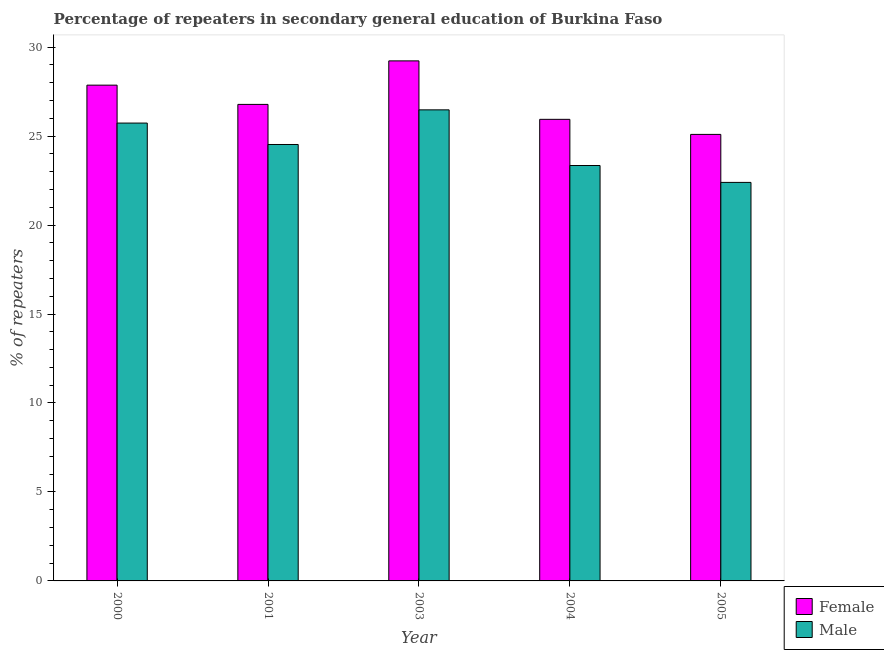How many different coloured bars are there?
Your answer should be compact. 2. How many groups of bars are there?
Your answer should be very brief. 5. Are the number of bars per tick equal to the number of legend labels?
Provide a succinct answer. Yes. How many bars are there on the 2nd tick from the left?
Provide a short and direct response. 2. What is the label of the 2nd group of bars from the left?
Give a very brief answer. 2001. In how many cases, is the number of bars for a given year not equal to the number of legend labels?
Make the answer very short. 0. What is the percentage of male repeaters in 2000?
Keep it short and to the point. 25.73. Across all years, what is the maximum percentage of female repeaters?
Your response must be concise. 29.23. Across all years, what is the minimum percentage of female repeaters?
Provide a short and direct response. 25.1. In which year was the percentage of male repeaters minimum?
Provide a succinct answer. 2005. What is the total percentage of male repeaters in the graph?
Make the answer very short. 122.48. What is the difference between the percentage of male repeaters in 2001 and that in 2005?
Offer a terse response. 2.13. What is the difference between the percentage of male repeaters in 2001 and the percentage of female repeaters in 2000?
Make the answer very short. -1.2. What is the average percentage of male repeaters per year?
Offer a terse response. 24.5. In how many years, is the percentage of female repeaters greater than 7 %?
Offer a very short reply. 5. What is the ratio of the percentage of male repeaters in 2001 to that in 2004?
Your response must be concise. 1.05. Is the difference between the percentage of male repeaters in 2001 and 2004 greater than the difference between the percentage of female repeaters in 2001 and 2004?
Make the answer very short. No. What is the difference between the highest and the second highest percentage of male repeaters?
Keep it short and to the point. 0.74. What is the difference between the highest and the lowest percentage of female repeaters?
Your answer should be compact. 4.13. Is the sum of the percentage of female repeaters in 2000 and 2003 greater than the maximum percentage of male repeaters across all years?
Your answer should be compact. Yes. What does the 2nd bar from the right in 2000 represents?
Ensure brevity in your answer.  Female. How many bars are there?
Your answer should be compact. 10. Are the values on the major ticks of Y-axis written in scientific E-notation?
Give a very brief answer. No. Does the graph contain any zero values?
Make the answer very short. No. How many legend labels are there?
Offer a very short reply. 2. What is the title of the graph?
Your response must be concise. Percentage of repeaters in secondary general education of Burkina Faso. What is the label or title of the X-axis?
Keep it short and to the point. Year. What is the label or title of the Y-axis?
Your answer should be very brief. % of repeaters. What is the % of repeaters in Female in 2000?
Provide a succinct answer. 27.86. What is the % of repeaters of Male in 2000?
Give a very brief answer. 25.73. What is the % of repeaters in Female in 2001?
Your response must be concise. 26.78. What is the % of repeaters in Male in 2001?
Provide a succinct answer. 24.53. What is the % of repeaters in Female in 2003?
Provide a short and direct response. 29.23. What is the % of repeaters of Male in 2003?
Provide a succinct answer. 26.48. What is the % of repeaters of Female in 2004?
Your answer should be compact. 25.94. What is the % of repeaters in Male in 2004?
Provide a short and direct response. 23.35. What is the % of repeaters of Female in 2005?
Provide a short and direct response. 25.1. What is the % of repeaters in Male in 2005?
Keep it short and to the point. 22.4. Across all years, what is the maximum % of repeaters of Female?
Give a very brief answer. 29.23. Across all years, what is the maximum % of repeaters in Male?
Make the answer very short. 26.48. Across all years, what is the minimum % of repeaters of Female?
Keep it short and to the point. 25.1. Across all years, what is the minimum % of repeaters of Male?
Your answer should be compact. 22.4. What is the total % of repeaters in Female in the graph?
Your answer should be very brief. 134.91. What is the total % of repeaters in Male in the graph?
Ensure brevity in your answer.  122.48. What is the difference between the % of repeaters in Female in 2000 and that in 2001?
Offer a terse response. 1.08. What is the difference between the % of repeaters in Male in 2000 and that in 2001?
Keep it short and to the point. 1.2. What is the difference between the % of repeaters in Female in 2000 and that in 2003?
Keep it short and to the point. -1.36. What is the difference between the % of repeaters of Male in 2000 and that in 2003?
Provide a succinct answer. -0.74. What is the difference between the % of repeaters in Female in 2000 and that in 2004?
Your answer should be compact. 1.92. What is the difference between the % of repeaters of Male in 2000 and that in 2004?
Offer a very short reply. 2.39. What is the difference between the % of repeaters of Female in 2000 and that in 2005?
Give a very brief answer. 2.77. What is the difference between the % of repeaters of Male in 2000 and that in 2005?
Your answer should be very brief. 3.33. What is the difference between the % of repeaters in Female in 2001 and that in 2003?
Provide a succinct answer. -2.45. What is the difference between the % of repeaters in Male in 2001 and that in 2003?
Make the answer very short. -1.95. What is the difference between the % of repeaters in Female in 2001 and that in 2004?
Your response must be concise. 0.84. What is the difference between the % of repeaters in Male in 2001 and that in 2004?
Ensure brevity in your answer.  1.18. What is the difference between the % of repeaters of Female in 2001 and that in 2005?
Your answer should be compact. 1.69. What is the difference between the % of repeaters in Male in 2001 and that in 2005?
Provide a short and direct response. 2.13. What is the difference between the % of repeaters of Female in 2003 and that in 2004?
Make the answer very short. 3.29. What is the difference between the % of repeaters in Male in 2003 and that in 2004?
Provide a short and direct response. 3.13. What is the difference between the % of repeaters in Female in 2003 and that in 2005?
Provide a short and direct response. 4.13. What is the difference between the % of repeaters of Male in 2003 and that in 2005?
Offer a very short reply. 4.08. What is the difference between the % of repeaters in Female in 2004 and that in 2005?
Offer a very short reply. 0.85. What is the difference between the % of repeaters in Male in 2004 and that in 2005?
Provide a succinct answer. 0.95. What is the difference between the % of repeaters of Female in 2000 and the % of repeaters of Male in 2001?
Offer a terse response. 3.34. What is the difference between the % of repeaters in Female in 2000 and the % of repeaters in Male in 2003?
Ensure brevity in your answer.  1.39. What is the difference between the % of repeaters of Female in 2000 and the % of repeaters of Male in 2004?
Offer a terse response. 4.52. What is the difference between the % of repeaters in Female in 2000 and the % of repeaters in Male in 2005?
Your answer should be compact. 5.47. What is the difference between the % of repeaters of Female in 2001 and the % of repeaters of Male in 2003?
Your response must be concise. 0.31. What is the difference between the % of repeaters in Female in 2001 and the % of repeaters in Male in 2004?
Ensure brevity in your answer.  3.43. What is the difference between the % of repeaters of Female in 2001 and the % of repeaters of Male in 2005?
Provide a short and direct response. 4.38. What is the difference between the % of repeaters in Female in 2003 and the % of repeaters in Male in 2004?
Keep it short and to the point. 5.88. What is the difference between the % of repeaters in Female in 2003 and the % of repeaters in Male in 2005?
Offer a terse response. 6.83. What is the difference between the % of repeaters in Female in 2004 and the % of repeaters in Male in 2005?
Keep it short and to the point. 3.54. What is the average % of repeaters of Female per year?
Give a very brief answer. 26.98. What is the average % of repeaters of Male per year?
Your response must be concise. 24.5. In the year 2000, what is the difference between the % of repeaters of Female and % of repeaters of Male?
Offer a terse response. 2.13. In the year 2001, what is the difference between the % of repeaters in Female and % of repeaters in Male?
Give a very brief answer. 2.25. In the year 2003, what is the difference between the % of repeaters in Female and % of repeaters in Male?
Give a very brief answer. 2.75. In the year 2004, what is the difference between the % of repeaters of Female and % of repeaters of Male?
Provide a succinct answer. 2.6. In the year 2005, what is the difference between the % of repeaters of Female and % of repeaters of Male?
Give a very brief answer. 2.7. What is the ratio of the % of repeaters in Female in 2000 to that in 2001?
Keep it short and to the point. 1.04. What is the ratio of the % of repeaters of Male in 2000 to that in 2001?
Your answer should be very brief. 1.05. What is the ratio of the % of repeaters of Female in 2000 to that in 2003?
Your answer should be compact. 0.95. What is the ratio of the % of repeaters of Male in 2000 to that in 2003?
Your answer should be compact. 0.97. What is the ratio of the % of repeaters in Female in 2000 to that in 2004?
Your answer should be compact. 1.07. What is the ratio of the % of repeaters of Male in 2000 to that in 2004?
Ensure brevity in your answer.  1.1. What is the ratio of the % of repeaters of Female in 2000 to that in 2005?
Make the answer very short. 1.11. What is the ratio of the % of repeaters in Male in 2000 to that in 2005?
Your response must be concise. 1.15. What is the ratio of the % of repeaters of Female in 2001 to that in 2003?
Offer a very short reply. 0.92. What is the ratio of the % of repeaters of Male in 2001 to that in 2003?
Provide a short and direct response. 0.93. What is the ratio of the % of repeaters in Female in 2001 to that in 2004?
Make the answer very short. 1.03. What is the ratio of the % of repeaters of Male in 2001 to that in 2004?
Your answer should be very brief. 1.05. What is the ratio of the % of repeaters of Female in 2001 to that in 2005?
Ensure brevity in your answer.  1.07. What is the ratio of the % of repeaters of Male in 2001 to that in 2005?
Make the answer very short. 1.1. What is the ratio of the % of repeaters in Female in 2003 to that in 2004?
Make the answer very short. 1.13. What is the ratio of the % of repeaters in Male in 2003 to that in 2004?
Keep it short and to the point. 1.13. What is the ratio of the % of repeaters in Female in 2003 to that in 2005?
Make the answer very short. 1.16. What is the ratio of the % of repeaters of Male in 2003 to that in 2005?
Make the answer very short. 1.18. What is the ratio of the % of repeaters of Female in 2004 to that in 2005?
Your response must be concise. 1.03. What is the ratio of the % of repeaters of Male in 2004 to that in 2005?
Offer a very short reply. 1.04. What is the difference between the highest and the second highest % of repeaters of Female?
Offer a very short reply. 1.36. What is the difference between the highest and the second highest % of repeaters of Male?
Keep it short and to the point. 0.74. What is the difference between the highest and the lowest % of repeaters in Female?
Provide a succinct answer. 4.13. What is the difference between the highest and the lowest % of repeaters of Male?
Keep it short and to the point. 4.08. 